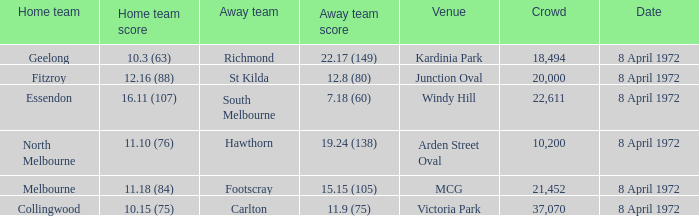Which Home team score has a Home team of geelong? 10.3 (63). Parse the table in full. {'header': ['Home team', 'Home team score', 'Away team', 'Away team score', 'Venue', 'Crowd', 'Date'], 'rows': [['Geelong', '10.3 (63)', 'Richmond', '22.17 (149)', 'Kardinia Park', '18,494', '8 April 1972'], ['Fitzroy', '12.16 (88)', 'St Kilda', '12.8 (80)', 'Junction Oval', '20,000', '8 April 1972'], ['Essendon', '16.11 (107)', 'South Melbourne', '7.18 (60)', 'Windy Hill', '22,611', '8 April 1972'], ['North Melbourne', '11.10 (76)', 'Hawthorn', '19.24 (138)', 'Arden Street Oval', '10,200', '8 April 1972'], ['Melbourne', '11.18 (84)', 'Footscray', '15.15 (105)', 'MCG', '21,452', '8 April 1972'], ['Collingwood', '10.15 (75)', 'Carlton', '11.9 (75)', 'Victoria Park', '37,070', '8 April 1972']]} 